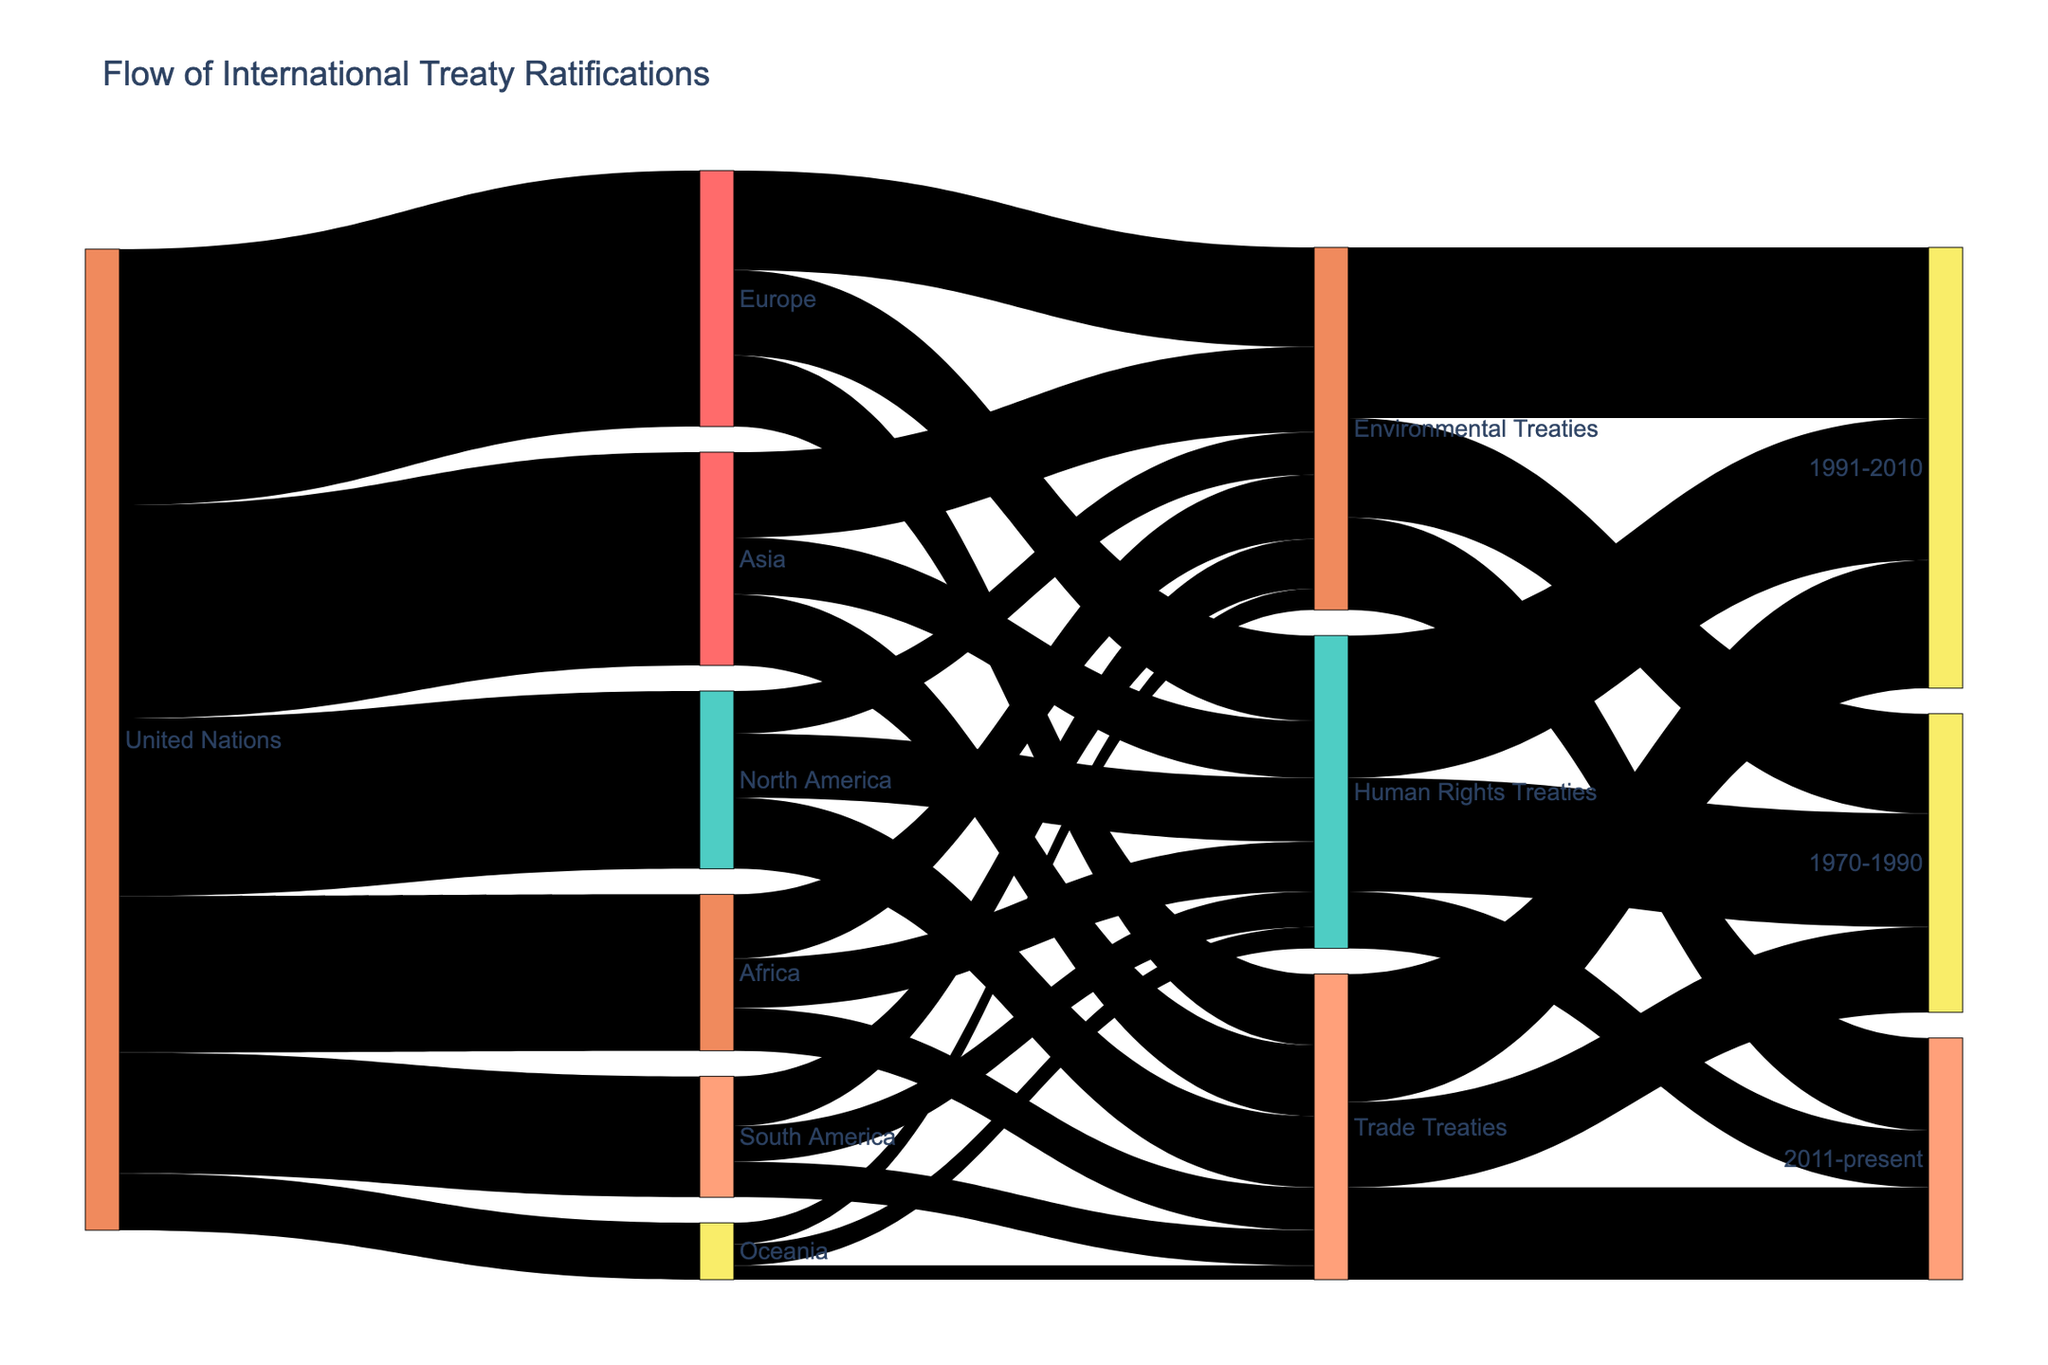What's the title of the figure? The title of the figure is displayed at the top center of the chart. It reads "Flow of International Treaty Ratifications".
Answer: Flow of International Treaty Ratifications Which region ratified the fewest treaties with the United Nations? To find the answer, look at the nodes connected directly to the "United Nations" node. Identify the node with the smallest connecting value. Oceania has the smallest value of 40.
Answer: Oceania What is the total number of Environmental Treaties ratified by all regions? Sum the values corresponding to the Environmental Treaties node: North America (30) + Europe (70) + Asia (60) + Africa (45) + South America (35) + Oceania (15).
Answer: 255 How does the number of Human Rights Treaties ratified by Europe compare to that of Asia? Compare the numbers directed from Europe to Human Rights Treaties and from Asia to Human Rights Treaties. Europe has 60, and Asia has 40.
Answer: Europe ratified 20 more treaties than Asia Which type of treaty had the most ratifications in the period 1991-2010? Check the values leading to the period 1991-2010 for Human Rights, Environmental, and Trade Treaties. Environmental Treaties have the highest value of 120.
Answer: Environmental Treaties What is the total number of Treaties ratified by North America? Add the values of all treaties ratified by North America: Human Rights (45) + Environmental (30) + Trade (50).
Answer: 125 Which type of treaty is least ratified in the 2011-present period? Check the values leading to the period 2011-present for Human Rights, Environmental, and Trade Treaties. Human Rights Treaties have the lowest value of 40.
Answer: Human Rights Treaties What is the combined number of Human Rights Treaties ratified by Africa and South America? Add the values leading to Human Rights Treaties from Africa (35) and South America (25).
Answer: 60 Between which nodes is the largest single flow of treaties? Look for the largest value in the figure. The largest value is the 180 treaties between United Nations and Europe.
Answer: United Nations and Europe How many regions have ratified trade treaties? Count the number of nodes connected directly to the Trade Treaties node. There are six regions: North America, Europe, Asia, Africa, South America, and Oceania.
Answer: 6 